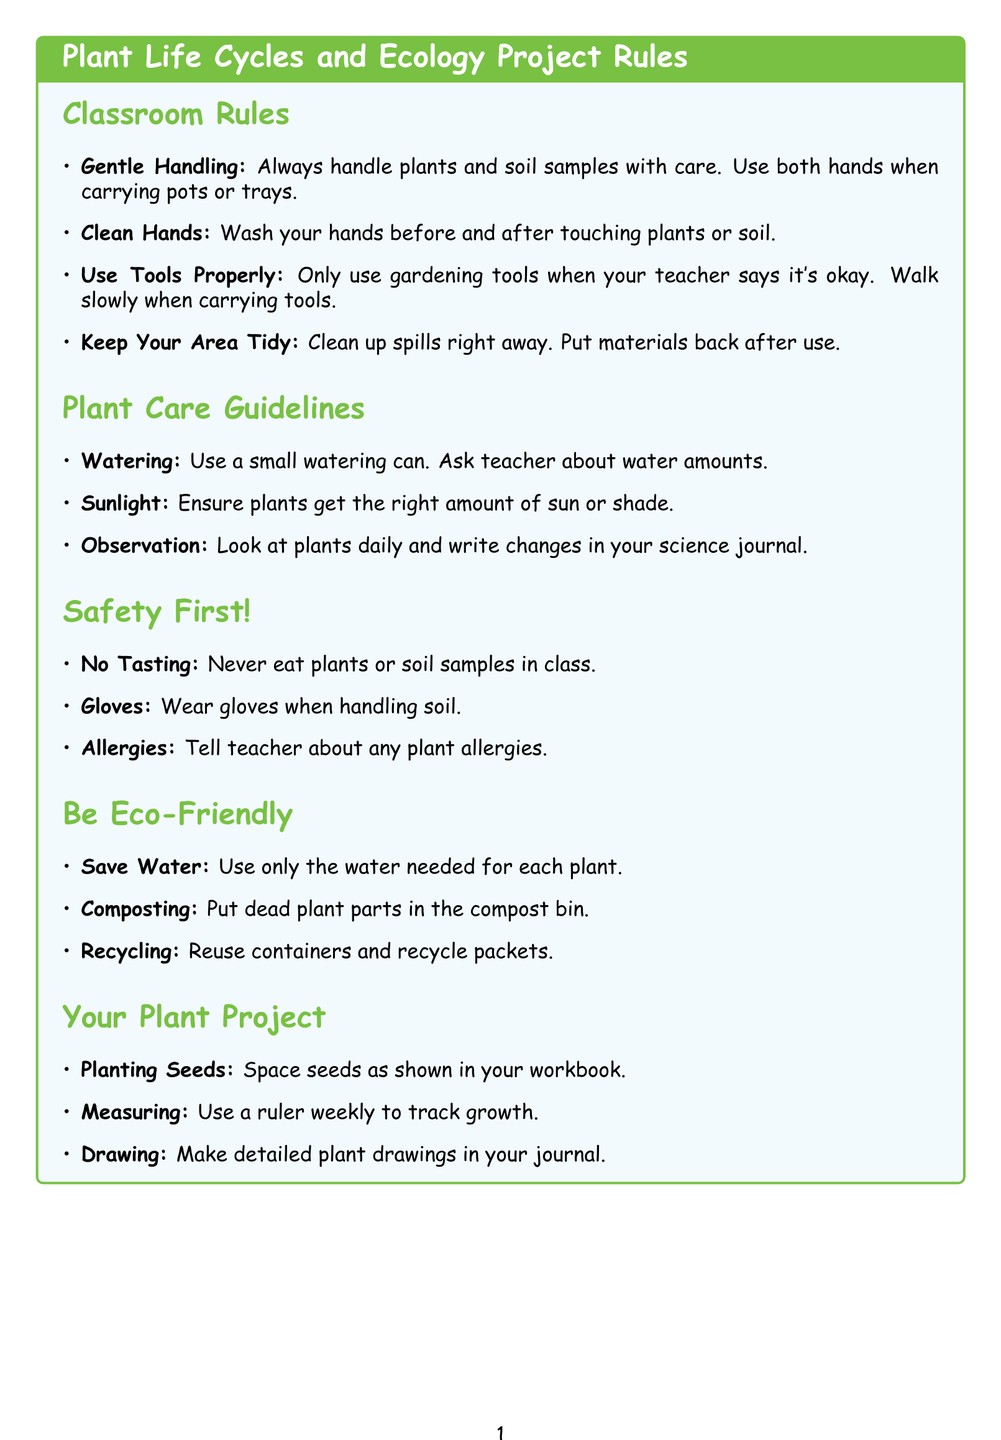What should you do before and after touching plants or soil? The document advises to wash your hands before and after touching plants or soil to prevent the spread of germs and protect the plants.
Answer: Wash your hands What is the guideline for handling plants? It states to always handle plants and soil samples with care and use both hands when carrying pots or trays to avoid accidents.
Answer: Gentle Handling How should you space seeds when planting? The document instructs to space seeds out as shown in your workbook and not to plant too many seeds in one pot.
Answer: As shown in your workbook What should you do with dead leaves and plant parts? It suggests putting dead leaves and plant parts in the classroom compost bin to help make new soil.
Answer: Classroom compost bin What safety precaution involves allergies? The document states to tell your teacher if you have any allergies to plants or pollen before starting the project.
Answer: Allergies How often should you measure plant growth? It is recommended to measure plant growth every week and write down the measurements in your plant growth chart.
Answer: Every week What is one way to be eco-friendly with water usage? The document advises to use only the amount of water needed for each plant to avoid waste.
Answer: Water Conservation What should you do with empty seed packets? The guideline suggests recycling any empty seed packets or plant labels.
Answer: Recycle What tool do you use for watering plants? It specifies to use a small watering can for watering plants gently.
Answer: Small watering can 